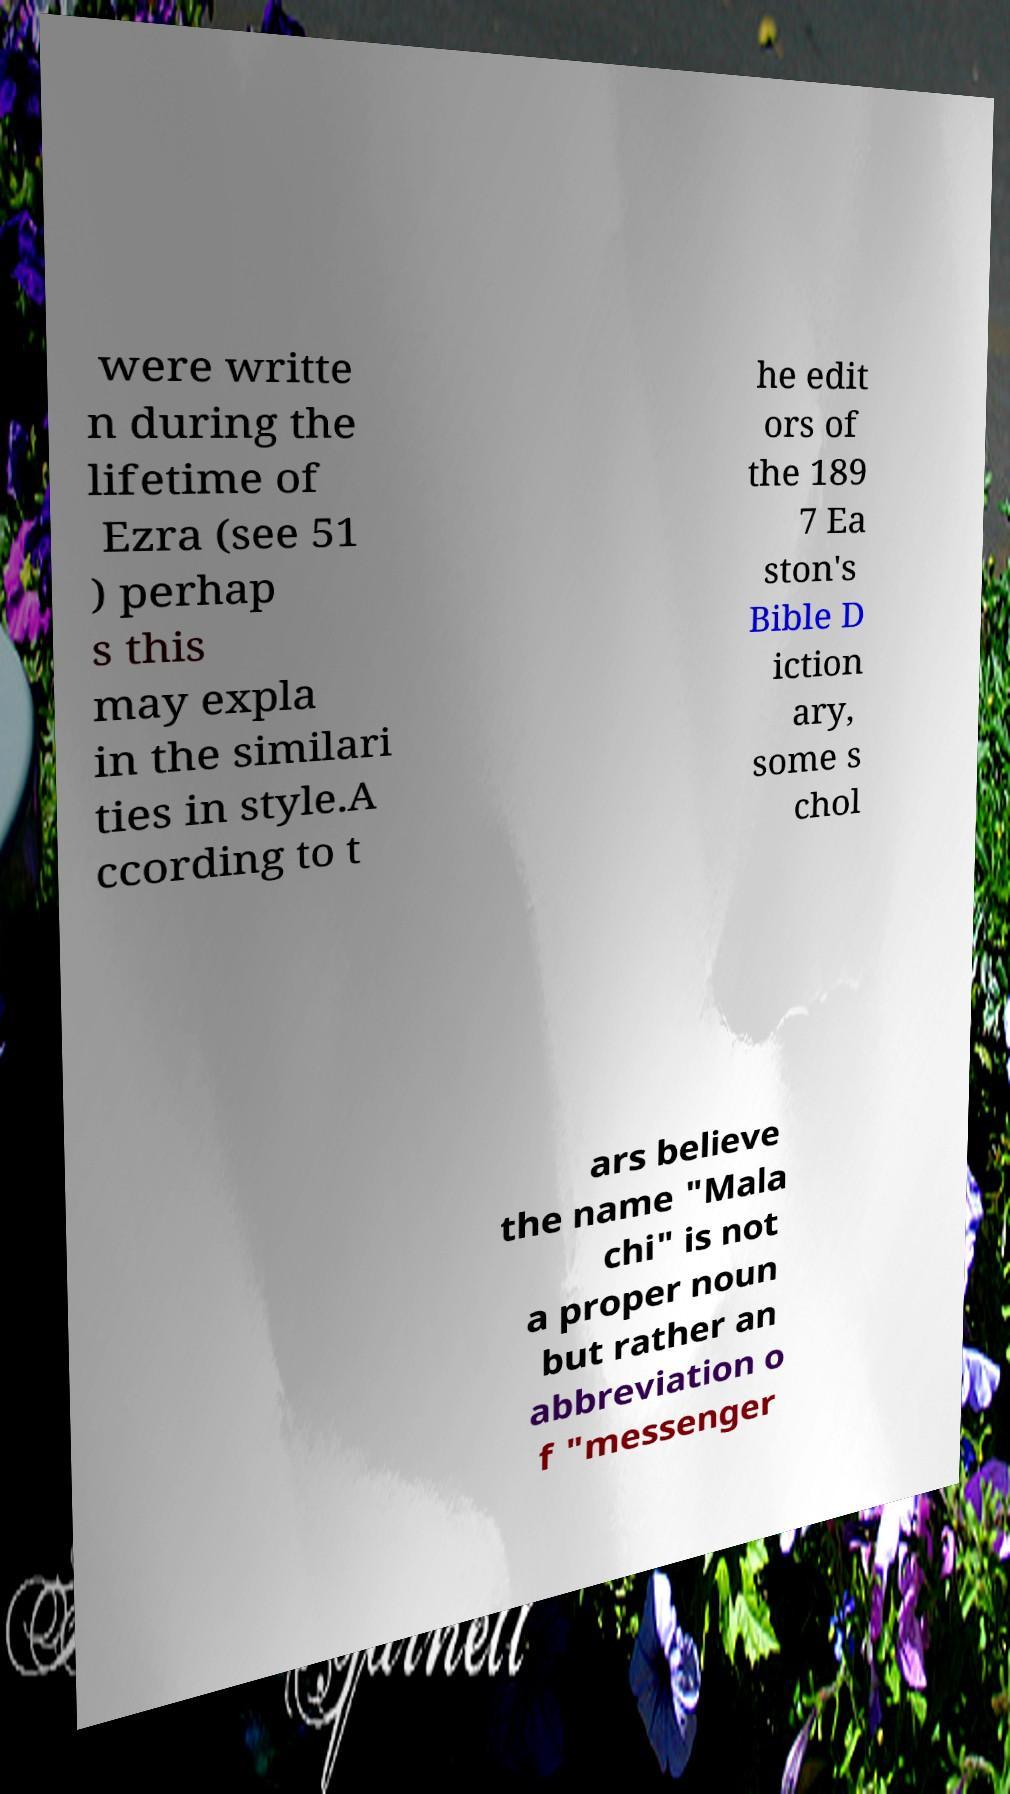For documentation purposes, I need the text within this image transcribed. Could you provide that? were writte n during the lifetime of Ezra (see 51 ) perhap s this may expla in the similari ties in style.A ccording to t he edit ors of the 189 7 Ea ston's Bible D iction ary, some s chol ars believe the name "Mala chi" is not a proper noun but rather an abbreviation o f "messenger 